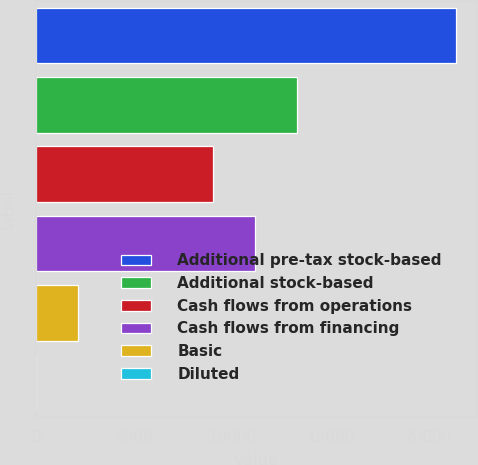Convert chart to OTSL. <chart><loc_0><loc_0><loc_500><loc_500><bar_chart><fcel>Additional pre-tax stock-based<fcel>Additional stock-based<fcel>Cash flows from operations<fcel>Cash flows from financing<fcel>Basic<fcel>Diluted<nl><fcel>21436<fcel>13299.2<fcel>9012<fcel>11155.6<fcel>2143.64<fcel>0.04<nl></chart> 